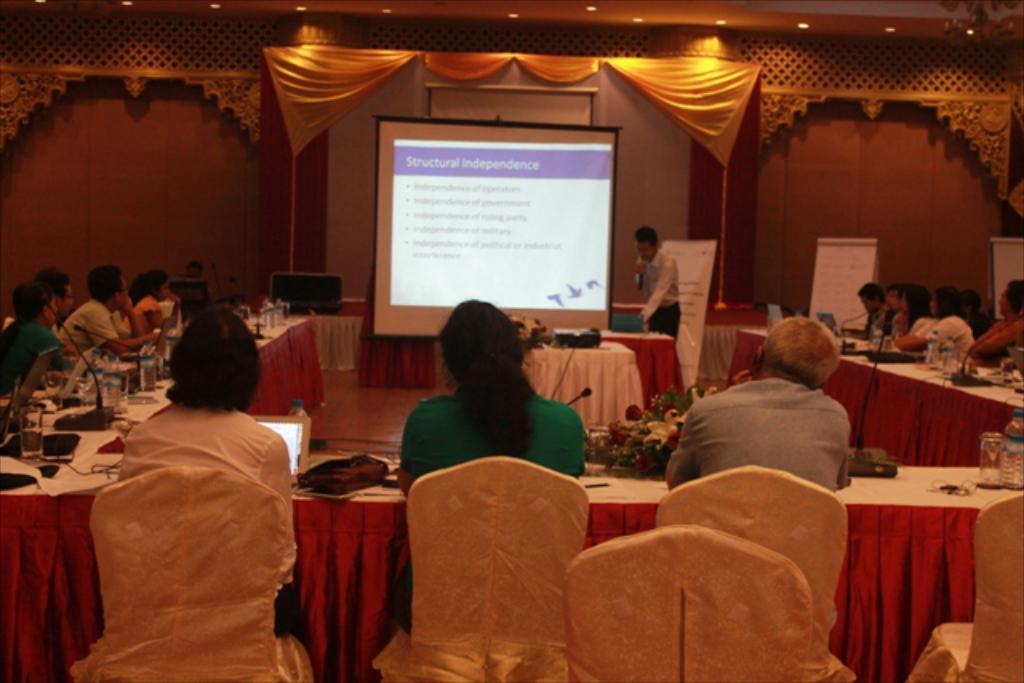How would you summarize this image in a sentence or two? In this picture I can see many people were sitting on the chair near to the table. On the table I can see the mics, bouquet, flowers, bag, laptops, cables, mouse, water glass, water bottles, tissue papers, papers and other objects. In the back there is a man who is standing near to the projector screen and projector machine. Behind him I can see the banners. At the top I can see the lights. 